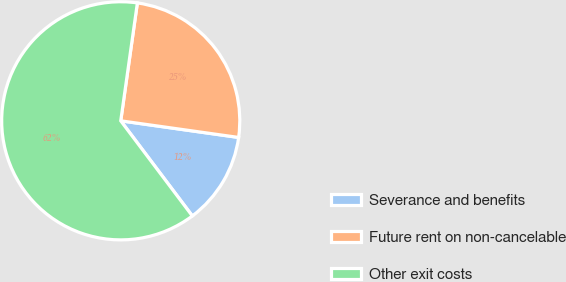Convert chart to OTSL. <chart><loc_0><loc_0><loc_500><loc_500><pie_chart><fcel>Severance and benefits<fcel>Future rent on non-cancelable<fcel>Other exit costs<nl><fcel>12.5%<fcel>25.0%<fcel>62.5%<nl></chart> 